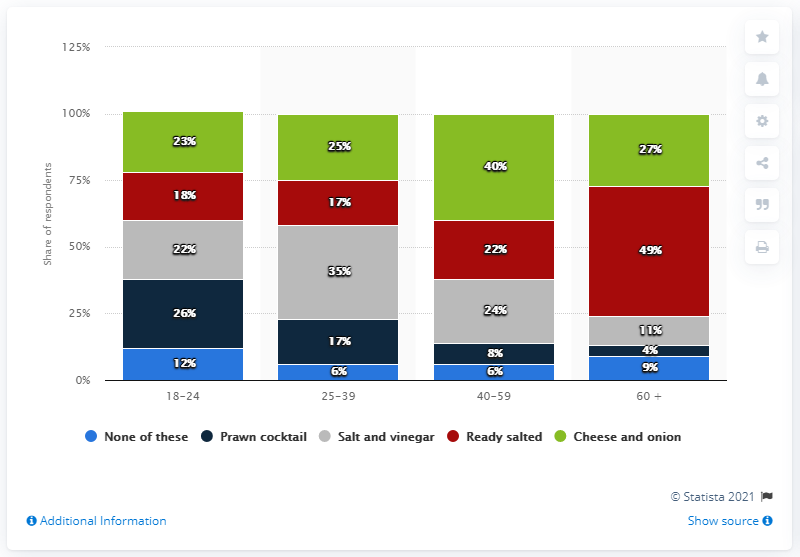Draw attention to some important aspects in this diagram. The color bar that is the biggest is green. The sum of the mode of None of these and the minimum of Prawn cocktail is 10. 